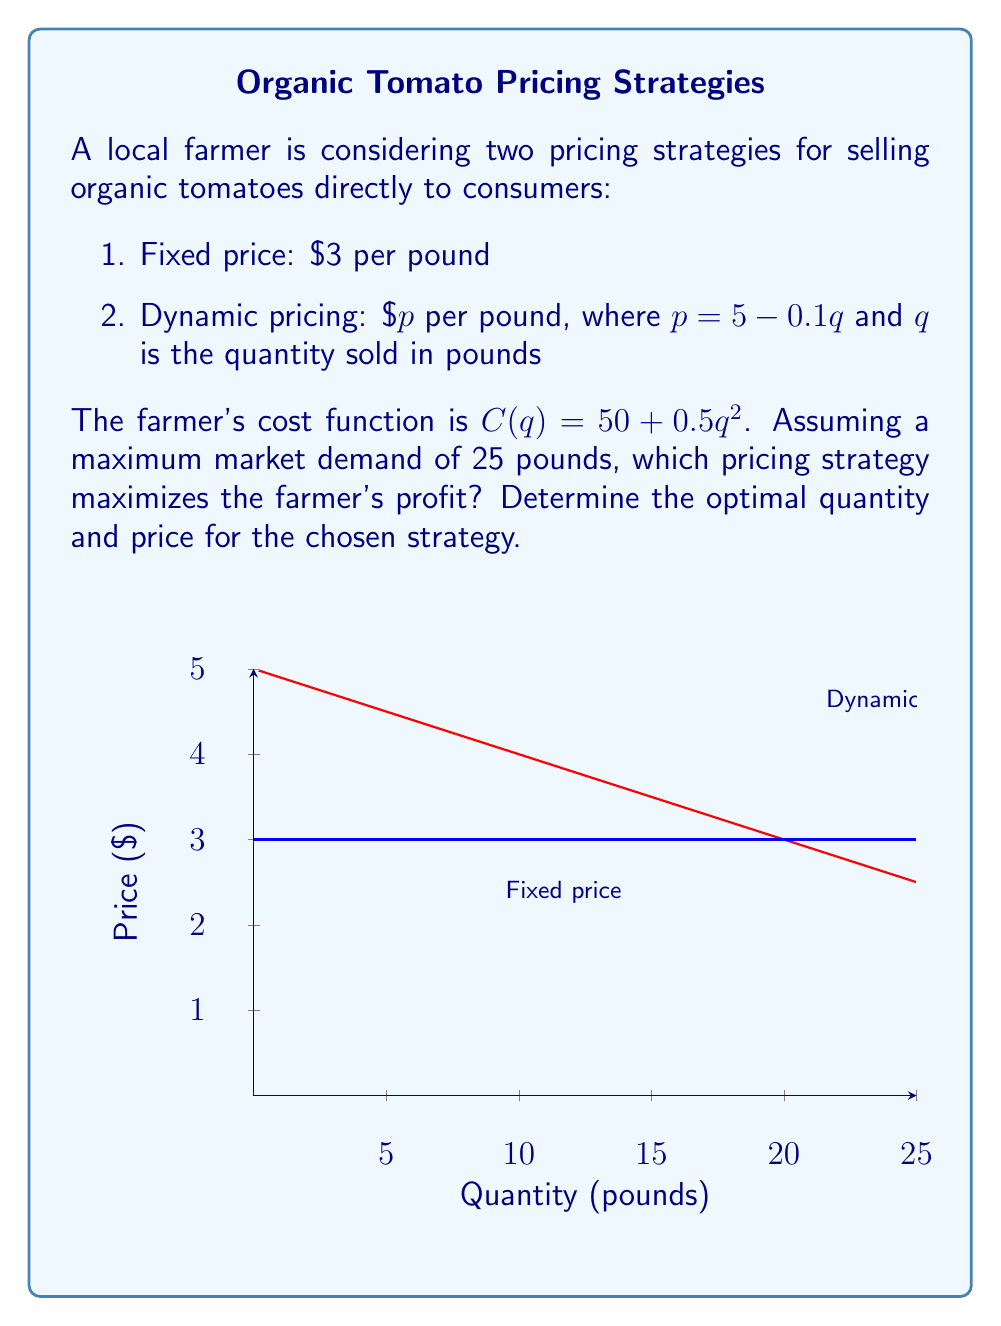Give your solution to this math problem. To solve this problem, we need to analyze both pricing strategies:

1. Fixed price strategy:
   Revenue function: $R(q) = 3q$
   Profit function: $\pi(q) = R(q) - C(q) = 3q - (50 + 0.5q^2)$
   To maximize profit, find where $\frac{d\pi}{dq} = 0$:
   $$\frac{d\pi}{dq} = 3 - q = 0$$
   $$q = 3$$
   Maximum profit: $\pi(3) = 3(3) - (50 + 0.5(3)^2) = -45.5$

2. Dynamic pricing strategy:
   Revenue function: $R(q) = pq = (5 - 0.1q)q = 5q - 0.1q^2$
   Profit function: $\pi(q) = R(q) - C(q) = 5q - 0.1q^2 - (50 + 0.5q^2)$
   $$\pi(q) = 5q - 0.6q^2 - 50$$
   To maximize profit, find where $\frac{d\pi}{dq} = 0$:
   $$\frac{d\pi}{dq} = 5 - 1.2q = 0$$
   $$q = \frac{25}{6} \approx 4.17$$
   Optimal price: $p = 5 - 0.1(\frac{25}{6}) = \frac{25}{6}$
   Maximum profit: $\pi(\frac{25}{6}) = 5(\frac{25}{6}) - 0.6(\frac{25}{6})^2 - 50 \approx -35.42$

The dynamic pricing strategy yields a higher profit (-$35.42 vs -$45.5), so it is the optimal choice.
Answer: Dynamic pricing; $q = \frac{25}{6}$ pounds, $p = \frac{25}{6}$ dollars per pound 